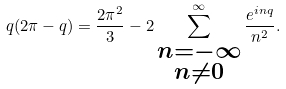<formula> <loc_0><loc_0><loc_500><loc_500>q ( 2 \pi - q ) = \frac { 2 \pi ^ { 2 } } { 3 } - 2 \sum ^ { \infty } _ { \substack { n = - \infty \\ n \neq 0 } } \frac { e ^ { i n q } } { n ^ { 2 } } .</formula> 